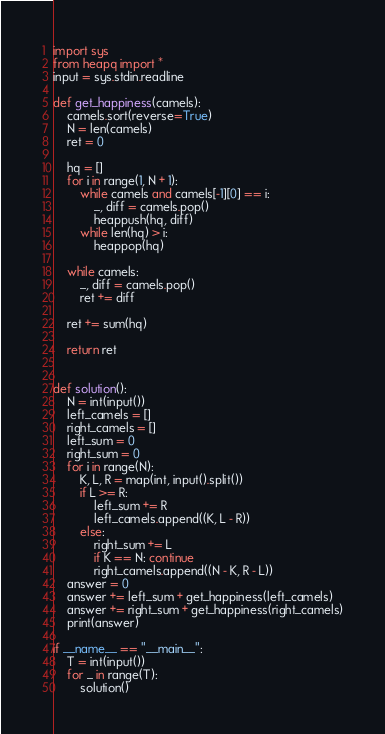<code> <loc_0><loc_0><loc_500><loc_500><_Python_>import sys
from heapq import *
input = sys.stdin.readline

def get_happiness(camels):
    camels.sort(reverse=True)
    N = len(camels)
    ret = 0

    hq = []
    for i in range(1, N + 1):
        while camels and camels[-1][0] == i:
            _, diff = camels.pop()
            heappush(hq, diff)
        while len(hq) > i:
            heappop(hq)

    while camels:
        _, diff = camels.pop()
        ret += diff

    ret += sum(hq)

    return ret


def solution():
    N = int(input())
    left_camels = []
    right_camels = []
    left_sum = 0
    right_sum = 0
    for i in range(N):
        K, L, R = map(int, input().split())
        if L >= R:
            left_sum += R
            left_camels.append((K, L - R))
        else:
            right_sum += L
            if K == N: continue
            right_camels.append((N - K, R - L))
    answer = 0
    answer += left_sum + get_happiness(left_camels)
    answer += right_sum + get_happiness(right_camels)
    print(answer)

if __name__ == "__main__":
    T = int(input())
    for _ in range(T):
        solution()</code> 